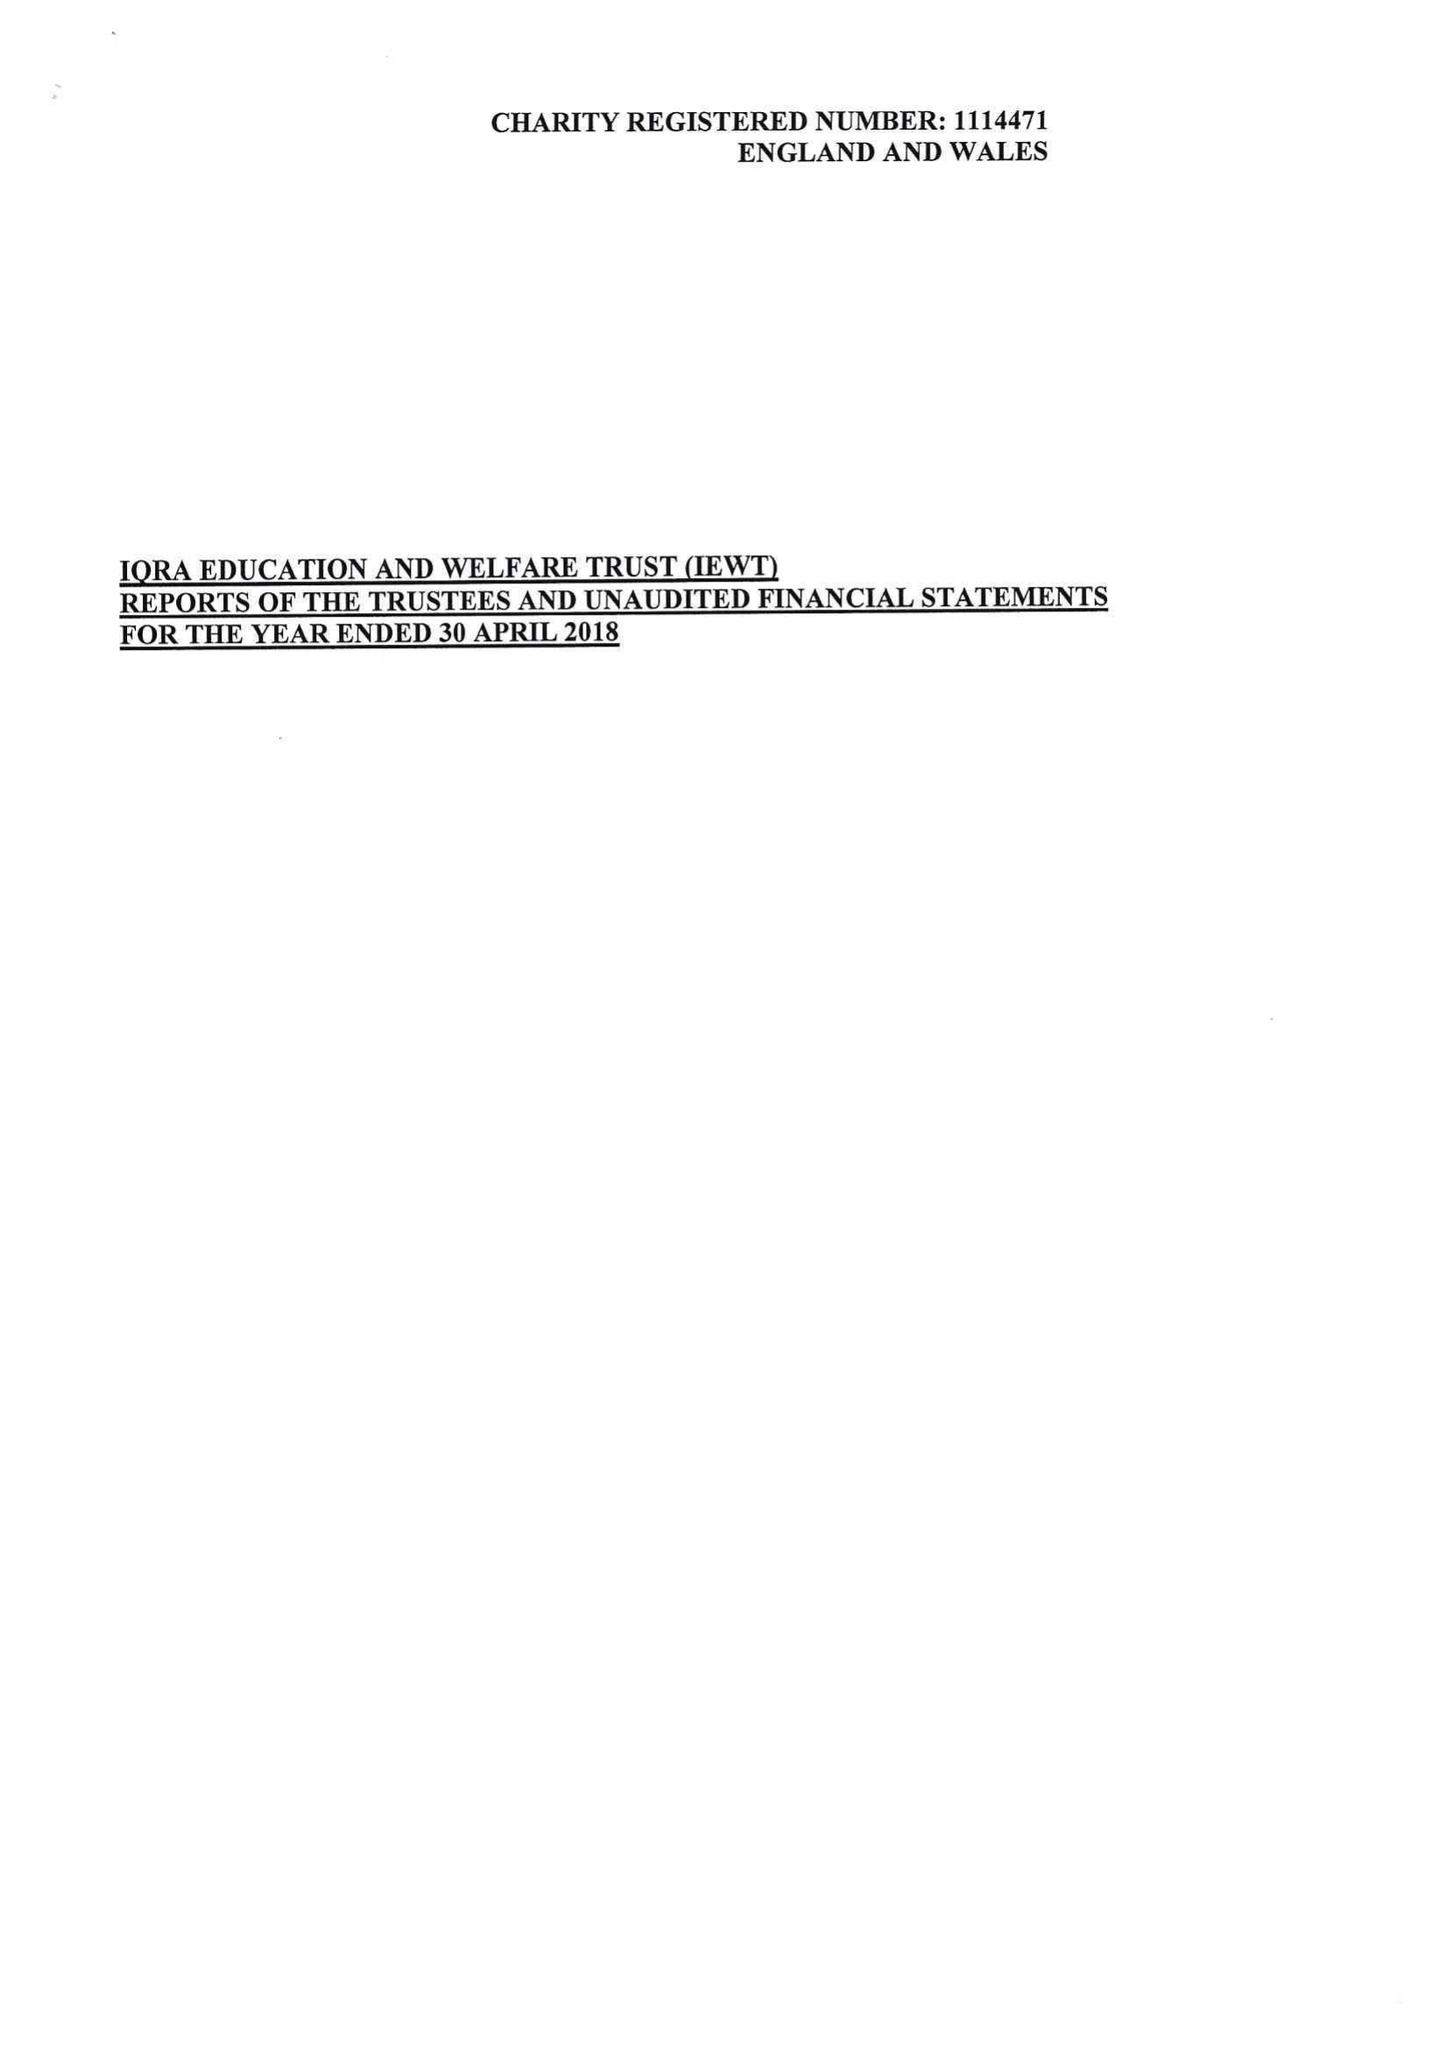What is the value for the address__post_town?
Answer the question using a single word or phrase. OLDHAM 